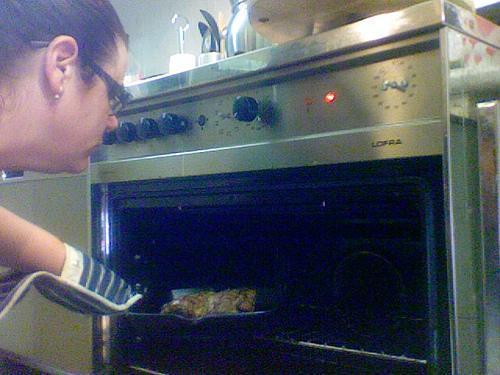How many people are visible?
Give a very brief answer. 1. 